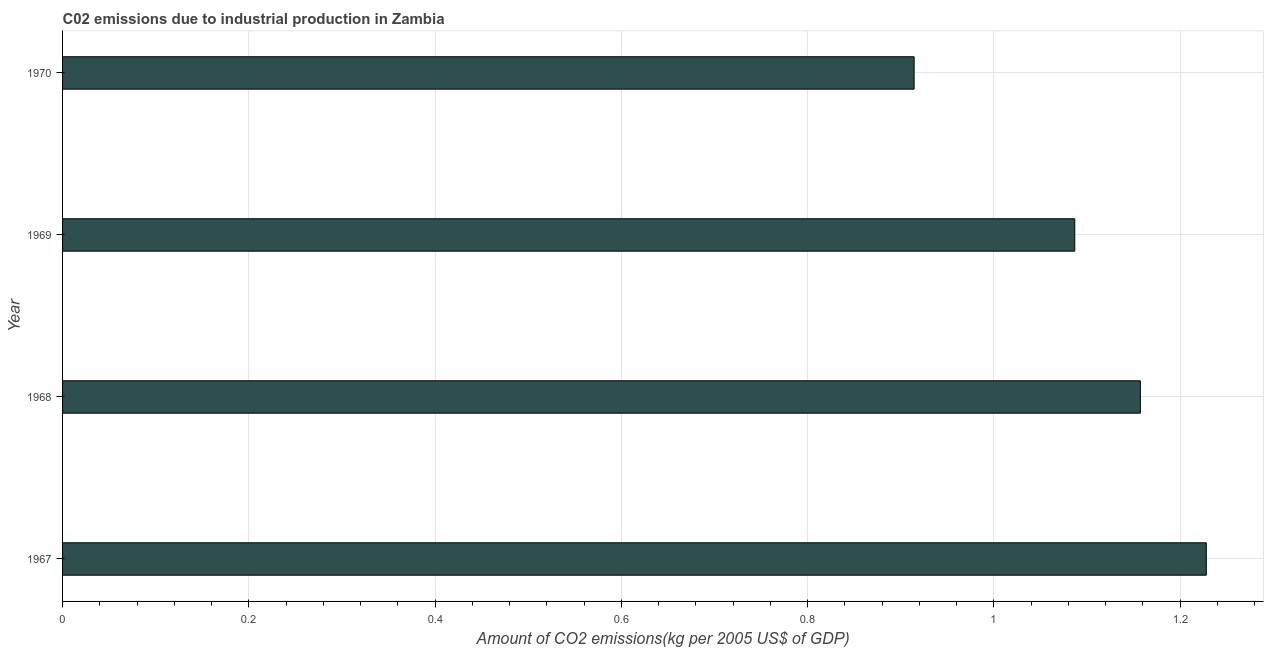Does the graph contain any zero values?
Offer a terse response. No. Does the graph contain grids?
Give a very brief answer. Yes. What is the title of the graph?
Offer a terse response. C02 emissions due to industrial production in Zambia. What is the label or title of the X-axis?
Your answer should be very brief. Amount of CO2 emissions(kg per 2005 US$ of GDP). What is the amount of co2 emissions in 1967?
Keep it short and to the point. 1.23. Across all years, what is the maximum amount of co2 emissions?
Offer a very short reply. 1.23. Across all years, what is the minimum amount of co2 emissions?
Give a very brief answer. 0.91. In which year was the amount of co2 emissions maximum?
Your answer should be compact. 1967. In which year was the amount of co2 emissions minimum?
Provide a short and direct response. 1970. What is the sum of the amount of co2 emissions?
Your answer should be compact. 4.39. What is the difference between the amount of co2 emissions in 1967 and 1968?
Provide a succinct answer. 0.07. What is the average amount of co2 emissions per year?
Give a very brief answer. 1.1. What is the median amount of co2 emissions?
Make the answer very short. 1.12. Do a majority of the years between 1967 and 1968 (inclusive) have amount of co2 emissions greater than 0.12 kg per 2005 US$ of GDP?
Your answer should be very brief. Yes. What is the ratio of the amount of co2 emissions in 1969 to that in 1970?
Provide a succinct answer. 1.19. Is the amount of co2 emissions in 1968 less than that in 1970?
Make the answer very short. No. What is the difference between the highest and the second highest amount of co2 emissions?
Ensure brevity in your answer.  0.07. Is the sum of the amount of co2 emissions in 1969 and 1970 greater than the maximum amount of co2 emissions across all years?
Your answer should be compact. Yes. What is the difference between the highest and the lowest amount of co2 emissions?
Your response must be concise. 0.31. How many bars are there?
Provide a succinct answer. 4. How many years are there in the graph?
Your response must be concise. 4. Are the values on the major ticks of X-axis written in scientific E-notation?
Your response must be concise. No. What is the Amount of CO2 emissions(kg per 2005 US$ of GDP) in 1967?
Give a very brief answer. 1.23. What is the Amount of CO2 emissions(kg per 2005 US$ of GDP) in 1968?
Offer a very short reply. 1.16. What is the Amount of CO2 emissions(kg per 2005 US$ of GDP) in 1969?
Your answer should be compact. 1.09. What is the Amount of CO2 emissions(kg per 2005 US$ of GDP) of 1970?
Offer a very short reply. 0.91. What is the difference between the Amount of CO2 emissions(kg per 2005 US$ of GDP) in 1967 and 1968?
Give a very brief answer. 0.07. What is the difference between the Amount of CO2 emissions(kg per 2005 US$ of GDP) in 1967 and 1969?
Your response must be concise. 0.14. What is the difference between the Amount of CO2 emissions(kg per 2005 US$ of GDP) in 1967 and 1970?
Your answer should be compact. 0.31. What is the difference between the Amount of CO2 emissions(kg per 2005 US$ of GDP) in 1968 and 1969?
Your answer should be very brief. 0.07. What is the difference between the Amount of CO2 emissions(kg per 2005 US$ of GDP) in 1968 and 1970?
Your response must be concise. 0.24. What is the difference between the Amount of CO2 emissions(kg per 2005 US$ of GDP) in 1969 and 1970?
Your response must be concise. 0.17. What is the ratio of the Amount of CO2 emissions(kg per 2005 US$ of GDP) in 1967 to that in 1968?
Make the answer very short. 1.06. What is the ratio of the Amount of CO2 emissions(kg per 2005 US$ of GDP) in 1967 to that in 1969?
Give a very brief answer. 1.13. What is the ratio of the Amount of CO2 emissions(kg per 2005 US$ of GDP) in 1967 to that in 1970?
Your answer should be compact. 1.34. What is the ratio of the Amount of CO2 emissions(kg per 2005 US$ of GDP) in 1968 to that in 1969?
Provide a short and direct response. 1.06. What is the ratio of the Amount of CO2 emissions(kg per 2005 US$ of GDP) in 1968 to that in 1970?
Provide a short and direct response. 1.27. What is the ratio of the Amount of CO2 emissions(kg per 2005 US$ of GDP) in 1969 to that in 1970?
Provide a short and direct response. 1.19. 